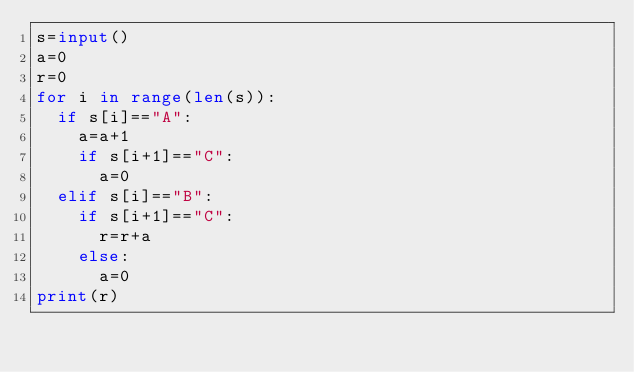Convert code to text. <code><loc_0><loc_0><loc_500><loc_500><_Python_>s=input()
a=0
r=0
for i in range(len(s)):
  if s[i]=="A":
    a=a+1
    if s[i+1]=="C":
      a=0
  elif s[i]=="B":
    if s[i+1]=="C":
      r=r+a
    else:
      a=0
print(r)</code> 